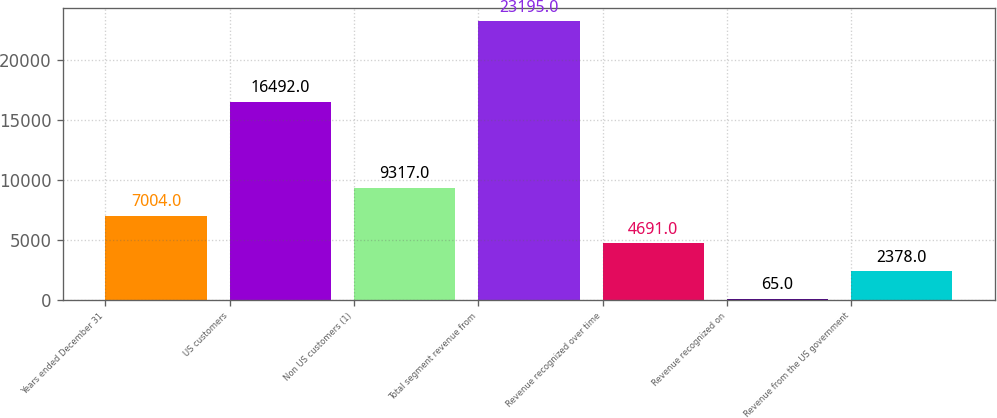<chart> <loc_0><loc_0><loc_500><loc_500><bar_chart><fcel>Years ended December 31<fcel>US customers<fcel>Non US customers (1)<fcel>Total segment revenue from<fcel>Revenue recognized over time<fcel>Revenue recognized on<fcel>Revenue from the US government<nl><fcel>7004<fcel>16492<fcel>9317<fcel>23195<fcel>4691<fcel>65<fcel>2378<nl></chart> 